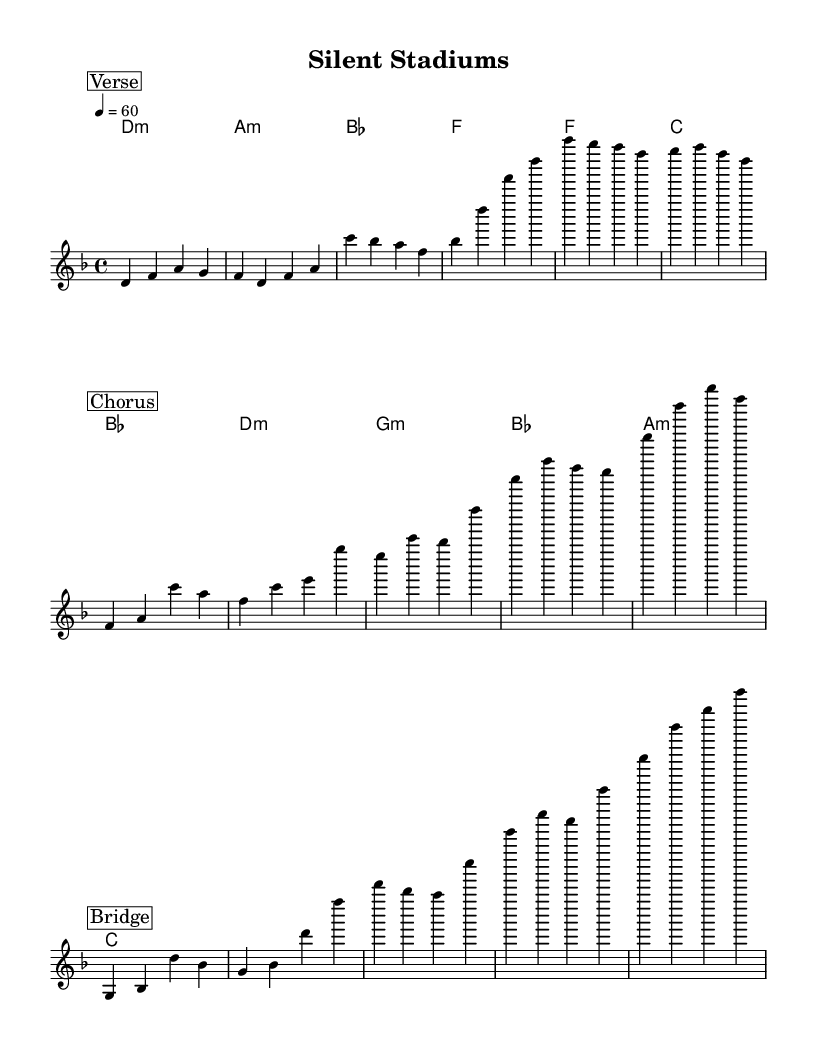What is the key signature of this music? The key signature shows that the music is in D minor, which has one flat (B flat) indicated in the key signature.
Answer: D minor What is the time signature of this piece? The time signature indicated in the music is 4/4, which means there are four beats per measure with a quarter note receiving one beat.
Answer: 4/4 What is the tempo marking for this music? The tempo marking indicates a speed of 60 beats per minute, which is a relatively slow tempo, suggesting a reflective mood appropriate for an introspective rock ballad.
Answer: 60 How many sections are there in this music? By examining the structure, we can see there is a Verse, Chorus, and Bridge, representing three distinct sections in the piece.
Answer: Three What chords are used in the harmonies? The chords listed in the harmonies are D minor, A minor, B flat, F, F, C, B flat, D minor, G minor, B flat, A minor, and C, offering various emotional colors typical in rock ballads.
Answer: D minor, A minor, B flat, F, F, C, B flat, D minor, G minor, A minor, C What is the mood conveyed by the tempo and key signature? The combination of the slow tempo of 60 beats per minute and the melancholic key of D minor often conveys a reflective or somber mood, typical for a ballad that deals with introspection and personal feelings.
Answer: Somber 